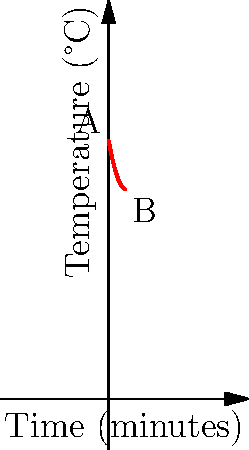As a bassist setting up your amplifier for a gig, you notice it's overheating. The graph shows the cooling curve of your amplifier after turning it off. If the ambient temperature is 25°C, what is the time constant τ of the cooling process in minutes? To find the time constant τ, we'll use the equation for exponential cooling:

$$ T(t) = T_a + (T_0 - T_a)e^{-t/τ} $$

Where:
- $T(t)$ is the temperature at time $t$
- $T_a$ is the ambient temperature (25°C)
- $T_0$ is the initial temperature (80°C)

Steps:
1. We need two points on the curve. Let's use:
   A(0, 80°C) and B(5, 65°C)

2. Plug these into the equation:
   For A: $80 = 25 + (80 - 25)e^{-0/τ}$
   For B: $65 = 25 + (80 - 25)e^{-5/τ}$

3. Simplify B equation:
   $65 - 25 = 55e^{-5/τ}$
   $40 = 55e^{-5/τ}$

4. Divide both sides by 55:
   $\frac{40}{55} = e^{-5/τ}$

5. Take natural log of both sides:
   $\ln(\frac{40}{55}) = -\frac{5}{τ}$

6. Solve for τ:
   $τ = -\frac{5}{\ln(\frac{40}{55})} ≈ 7.21$ minutes

Therefore, the time constant τ is approximately 7.21 minutes.
Answer: 7.21 minutes 